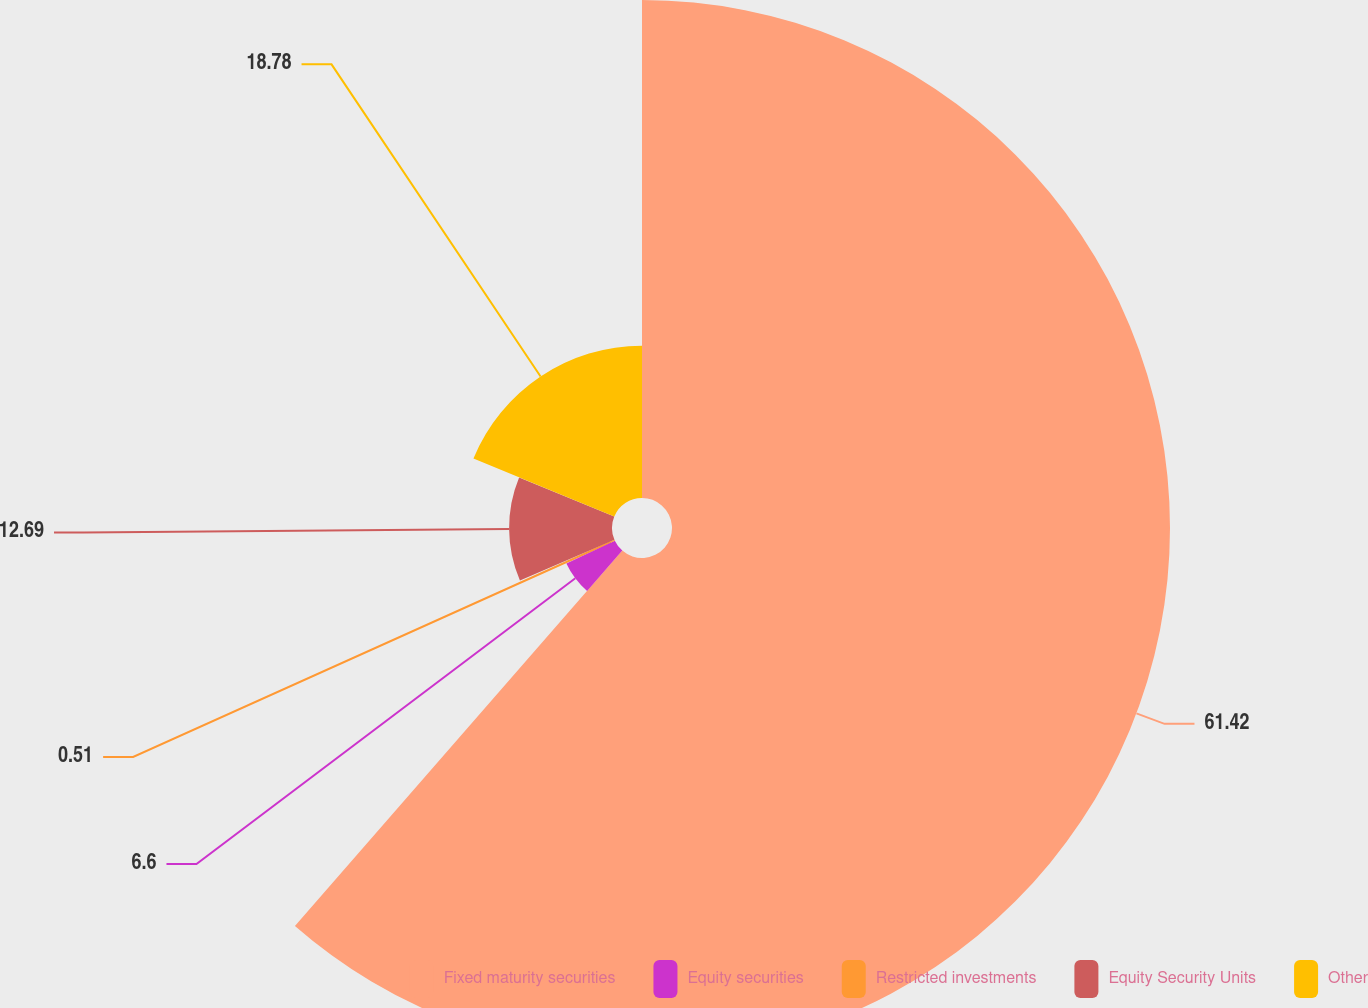Convert chart to OTSL. <chart><loc_0><loc_0><loc_500><loc_500><pie_chart><fcel>Fixed maturity securities<fcel>Equity securities<fcel>Restricted investments<fcel>Equity Security Units<fcel>Other<nl><fcel>61.41%<fcel>6.6%<fcel>0.51%<fcel>12.69%<fcel>18.78%<nl></chart> 